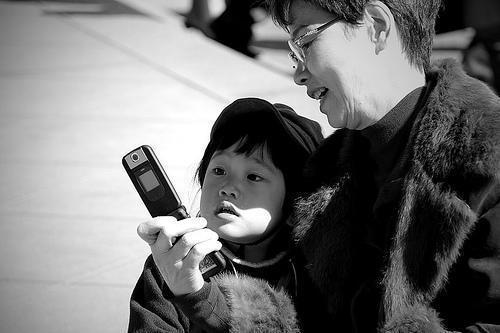What is she doing with the child?
Choose the correct response, then elucidate: 'Answer: answer
Rationale: rationale.'
Options: Holding captive, teaching reading, feeding them, showing phone. Answer: showing phone.
Rationale: The kid is using a phone. 